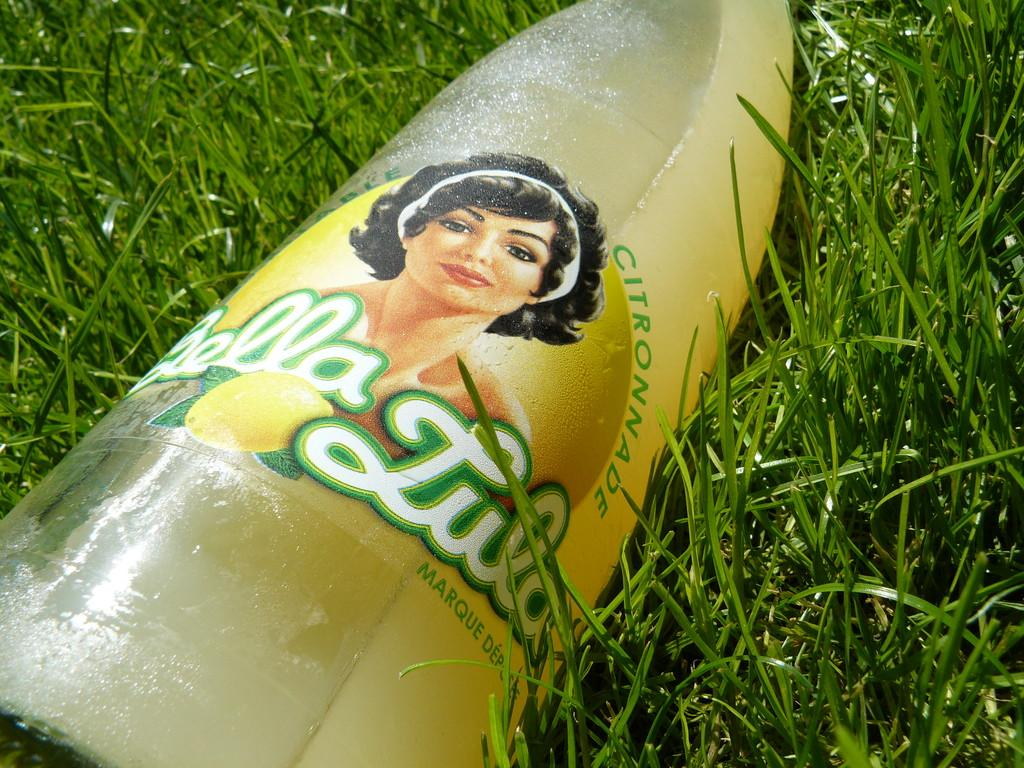What object can be seen in the image? There is a bottle in the image. Where is the bottle located? The bottle is on the grass. Is the queen holding the bottle in the image? There is no queen present in the image, and therefore she cannot be holding the bottle. 